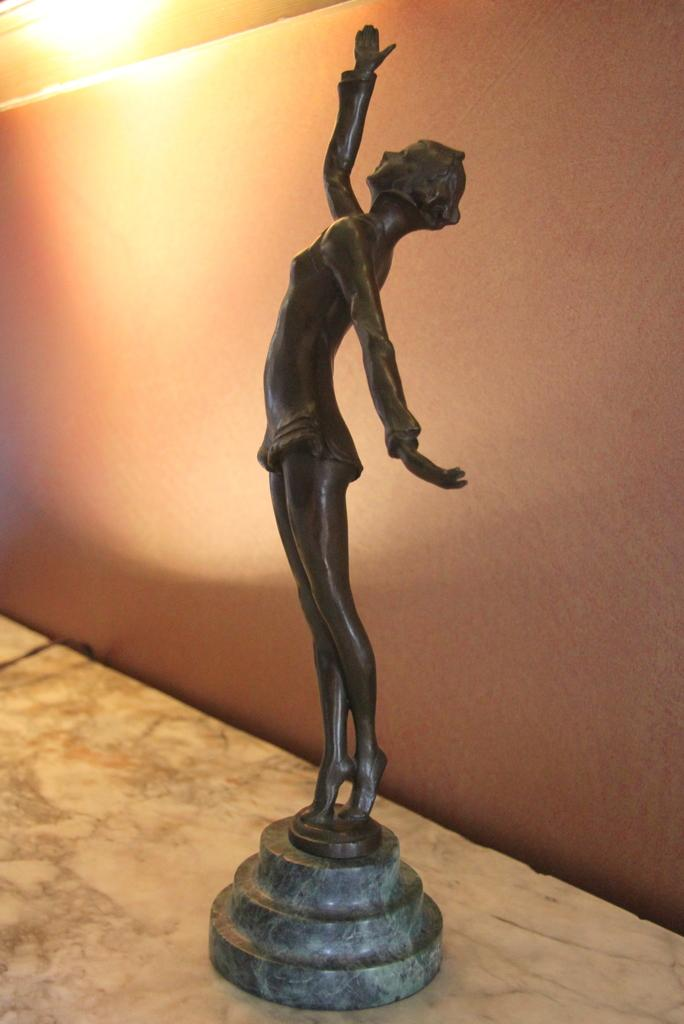What is the main subject of the image? There is a sculpture of a person in the image. What is the sculpture standing on? The sculpture is standing on a stone. What type of surface is visible in the image? The image appears to depict a floor. What architectural element can be seen in the image? There is a wall in the image. What object might provide illumination in the image? At the top left side of the image, there is an object that resembles a light. How many visitors are present in the image? There is no indication of any visitors in the image; it primarily features a sculpture of a person standing on a stone. 